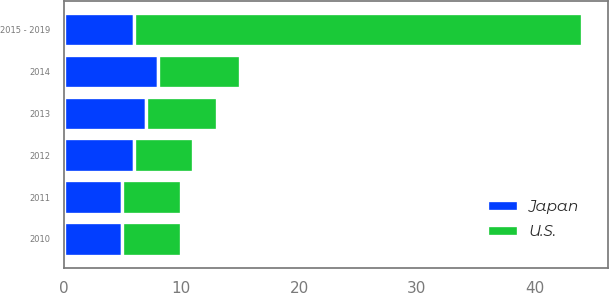<chart> <loc_0><loc_0><loc_500><loc_500><stacked_bar_chart><ecel><fcel>2010<fcel>2011<fcel>2012<fcel>2013<fcel>2014<fcel>2015 - 2019<nl><fcel>U.S.<fcel>5<fcel>5<fcel>5<fcel>6<fcel>7<fcel>38<nl><fcel>Japan<fcel>5<fcel>5<fcel>6<fcel>7<fcel>8<fcel>6<nl></chart> 